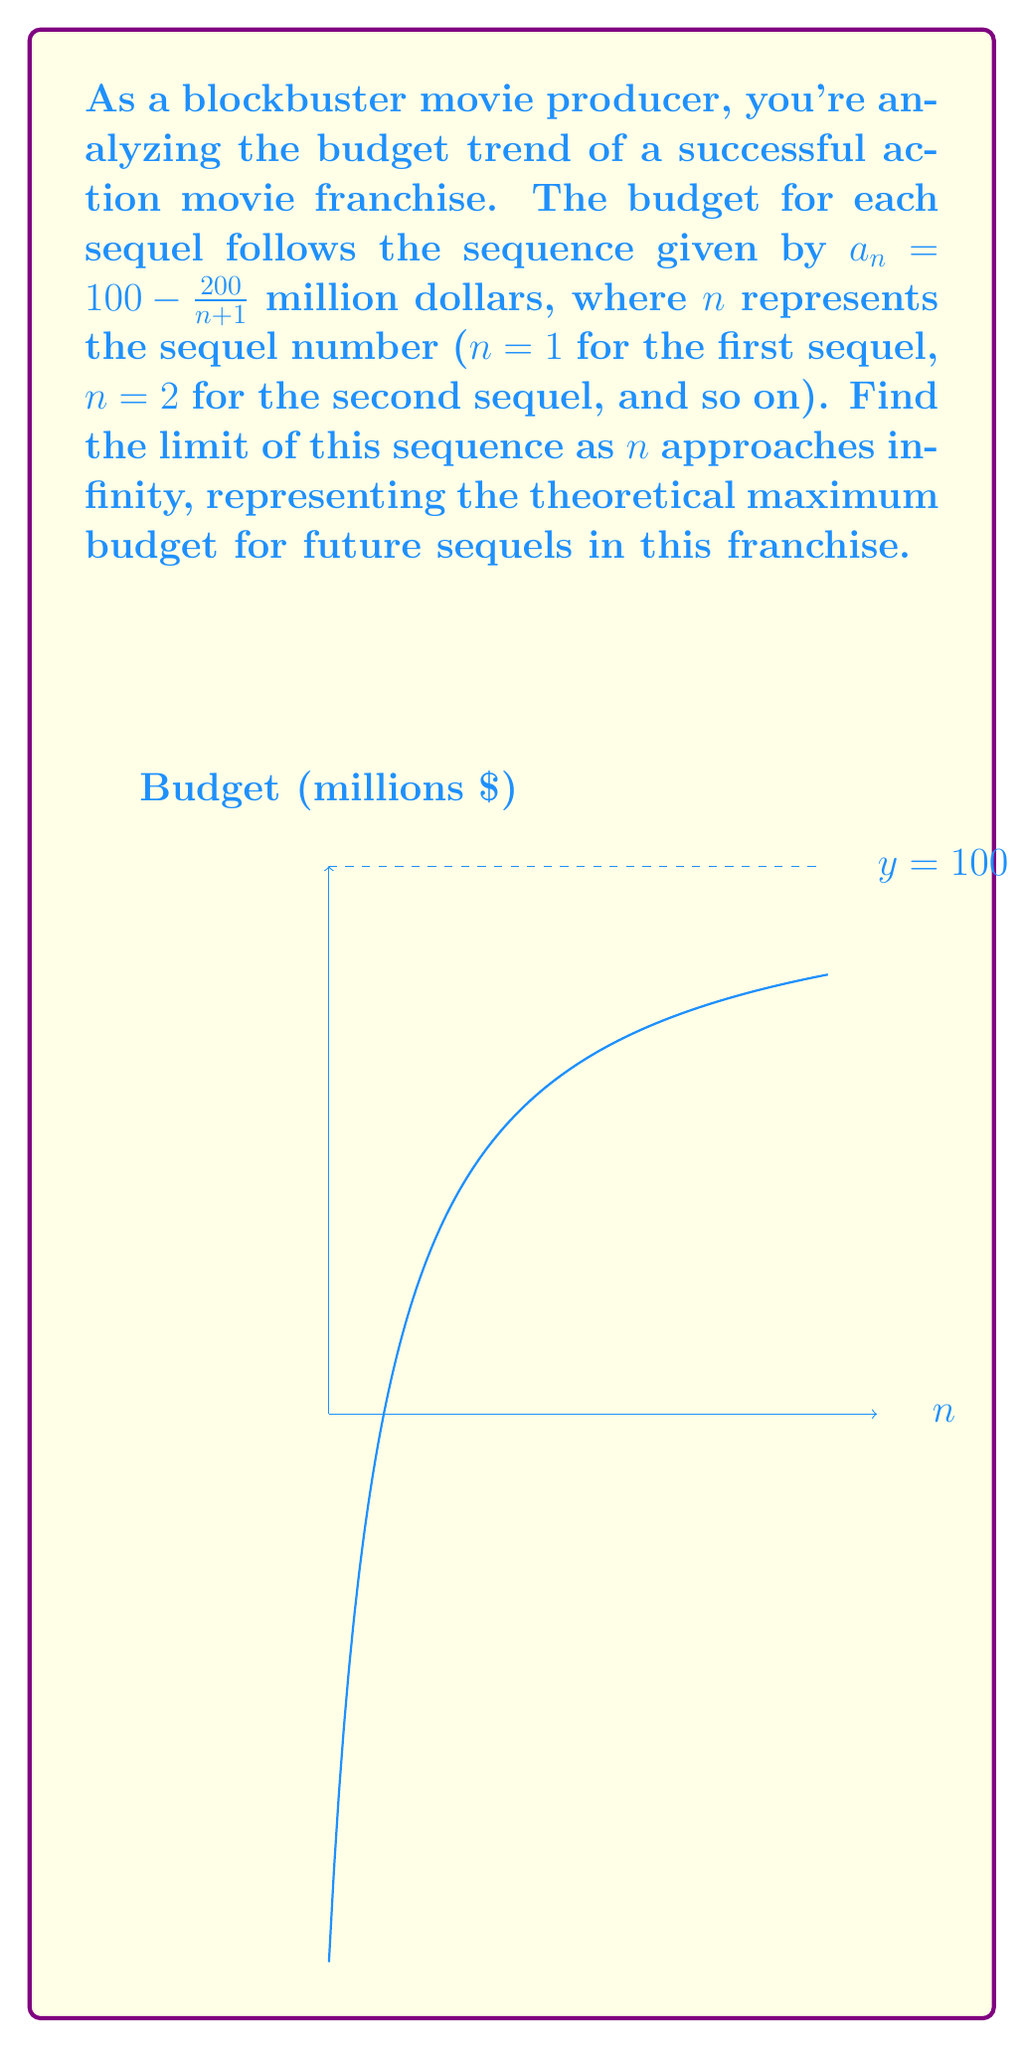Provide a solution to this math problem. Let's approach this step-by-step:

1) We're given the sequence $a_n = 100 - \frac{200}{n+1}$

2) To find the limit as n approaches infinity, we need to evaluate:

   $$\lim_{n \to \infty} (100 - \frac{200}{n+1})$$

3) We can split this into two parts:

   $$\lim_{n \to \infty} 100 - \lim_{n \to \infty} \frac{200}{n+1}$$

4) The first part is simple: $\lim_{n \to \infty} 100 = 100$

5) For the second part:
   
   $$\lim_{n \to \infty} \frac{200}{n+1}$$
   
   As n approaches infinity, n+1 also approaches infinity, and any constant divided by infinity approaches 0.

6) Therefore:

   $$\lim_{n \to \infty} \frac{200}{n+1} = 0$$

7) Putting it back together:

   $$\lim_{n \to \infty} (100 - \frac{200}{n+1}) = 100 - 0 = 100$$

This means that as the number of sequels increases indefinitely, the budget approaches but never quite reaches $100 million.
Answer: $100$ million 